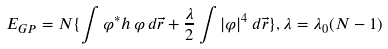Convert formula to latex. <formula><loc_0><loc_0><loc_500><loc_500>E _ { G P } = N \{ \int \varphi ^ { * } h \, \varphi \, d \vec { r } + \frac { \lambda } { 2 } \int | \varphi | ^ { 4 } \, d \vec { r } \} , \lambda = \lambda _ { 0 } ( N - 1 )</formula> 